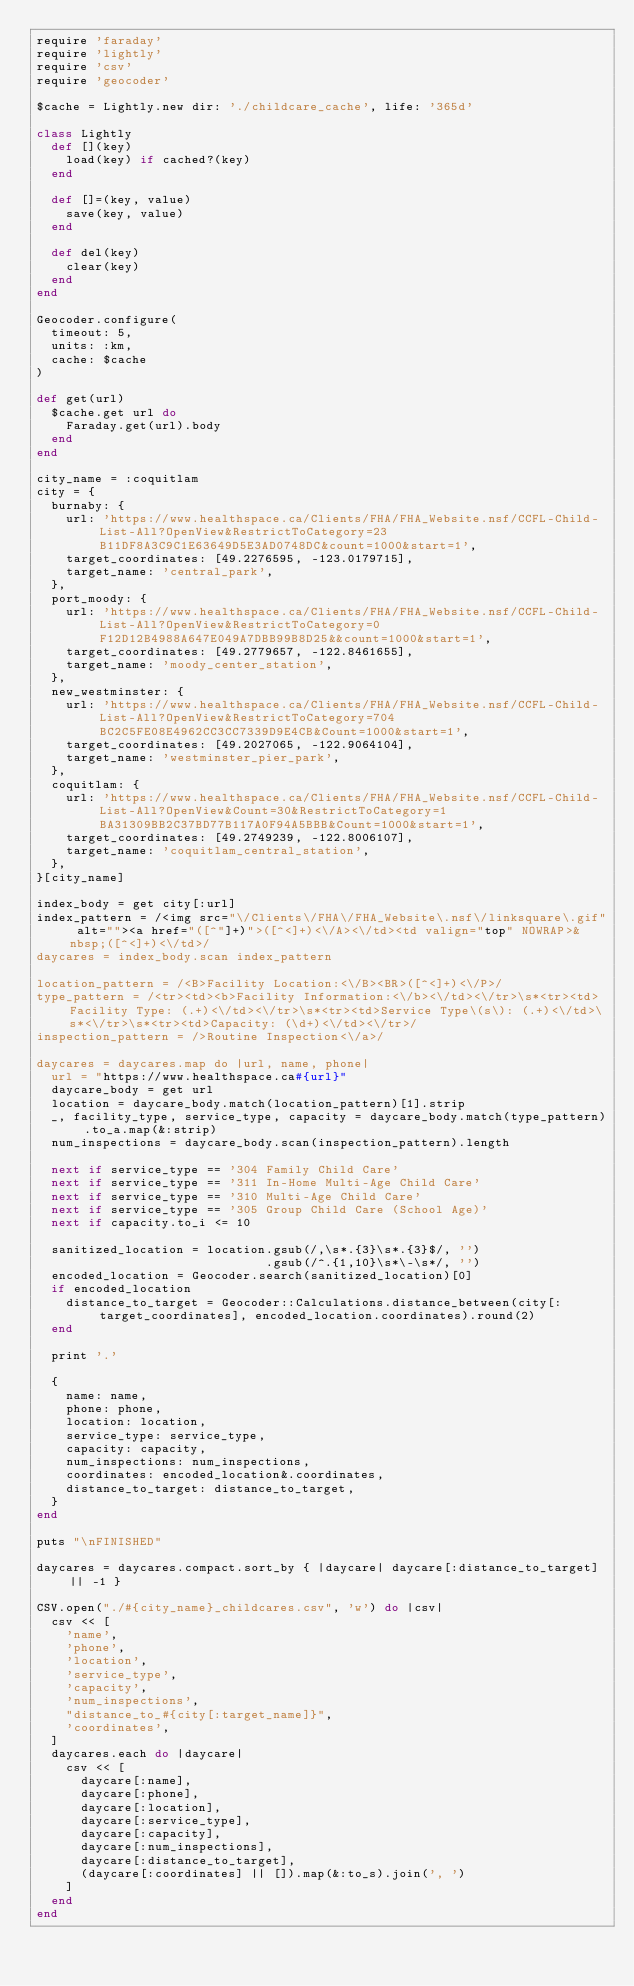<code> <loc_0><loc_0><loc_500><loc_500><_Ruby_>require 'faraday'
require 'lightly'
require 'csv'
require 'geocoder'

$cache = Lightly.new dir: './childcare_cache', life: '365d'

class Lightly
  def [](key)
    load(key) if cached?(key)
  end

  def []=(key, value)
    save(key, value)
  end

  def del(key)
    clear(key)
  end
end

Geocoder.configure(
  timeout: 5,
  units: :km,
  cache: $cache
)

def get(url)
  $cache.get url do
    Faraday.get(url).body
  end
end

city_name = :coquitlam
city = {
  burnaby: {
    url: 'https://www.healthspace.ca/Clients/FHA/FHA_Website.nsf/CCFL-Child-List-All?OpenView&RestrictToCategory=23B11DF8A3C9C1E63649D5E3AD0748DC&count=1000&start=1',
    target_coordinates: [49.2276595, -123.0179715],
    target_name: 'central_park',
  },
  port_moody: {
    url: 'https://www.healthspace.ca/Clients/FHA/FHA_Website.nsf/CCFL-Child-List-All?OpenView&RestrictToCategory=0F12D12B4988A647E049A7DBB99B8D25&&count=1000&start=1',
    target_coordinates: [49.2779657, -122.8461655],
    target_name: 'moody_center_station',
  },
  new_westminster: {
    url: 'https://www.healthspace.ca/Clients/FHA/FHA_Website.nsf/CCFL-Child-List-All?OpenView&RestrictToCategory=704BC2C5FE08E4962CC3CC7339D9E4CB&Count=1000&start=1',
    target_coordinates: [49.2027065, -122.9064104],
    target_name: 'westminster_pier_park',
  },
  coquitlam: {
    url: 'https://www.healthspace.ca/Clients/FHA/FHA_Website.nsf/CCFL-Child-List-All?OpenView&Count=30&RestrictToCategory=1BA31309BB2C37BD77B117A0F94A5BBB&Count=1000&start=1',
    target_coordinates: [49.2749239, -122.8006107],
    target_name: 'coquitlam_central_station',
  },
}[city_name]

index_body = get city[:url]
index_pattern = /<img src="\/Clients\/FHA\/FHA_Website\.nsf\/linksquare\.gif" alt=""><a href="([^"]+)">([^<]+)<\/A><\/td><td valign="top" NOWRAP>&nbsp;([^<]+)<\/td>/
daycares = index_body.scan index_pattern

location_pattern = /<B>Facility Location:<\/B><BR>([^<]+)<\/P>/
type_pattern = /<tr><td><b>Facility Information:<\/b><\/td><\/tr>\s*<tr><td>Facility Type: (.+)<\/td><\/tr>\s*<tr><td>Service Type\(s\): (.+)<\/td>\s*<\/tr>\s*<tr><td>Capacity: (\d+)<\/td><\/tr>/
inspection_pattern = />Routine Inspection<\/a>/

daycares = daycares.map do |url, name, phone|
  url = "https://www.healthspace.ca#{url}"
  daycare_body = get url
  location = daycare_body.match(location_pattern)[1].strip
  _, facility_type, service_type, capacity = daycare_body.match(type_pattern).to_a.map(&:strip)
  num_inspections = daycare_body.scan(inspection_pattern).length

  next if service_type == '304 Family Child Care'
  next if service_type == '311 In-Home Multi-Age Child Care'
  next if service_type == '310 Multi-Age Child Care'
  next if service_type == '305 Group Child Care (School Age)'
  next if capacity.to_i <= 10

  sanitized_location = location.gsub(/,\s*.{3}\s*.{3}$/, '')
                               .gsub(/^.{1,10}\s*\-\s*/, '')
  encoded_location = Geocoder.search(sanitized_location)[0]
  if encoded_location
    distance_to_target = Geocoder::Calculations.distance_between(city[:target_coordinates], encoded_location.coordinates).round(2)
  end

  print '.'

  {
    name: name,
    phone: phone,
    location: location,
    service_type: service_type,
    capacity: capacity,
    num_inspections: num_inspections,
    coordinates: encoded_location&.coordinates,
    distance_to_target: distance_to_target,
  }
end

puts "\nFINISHED"

daycares = daycares.compact.sort_by { |daycare| daycare[:distance_to_target] || -1 }

CSV.open("./#{city_name}_childcares.csv", 'w') do |csv|
  csv << [
    'name',
    'phone',
    'location',
    'service_type',
    'capacity',
    'num_inspections',
    "distance_to_#{city[:target_name]}",
    'coordinates',
  ]
  daycares.each do |daycare|
    csv << [
      daycare[:name],
      daycare[:phone],
      daycare[:location],
      daycare[:service_type],
      daycare[:capacity],
      daycare[:num_inspections],
      daycare[:distance_to_target],
      (daycare[:coordinates] || []).map(&:to_s).join(', ')
    ]
  end
end
</code> 